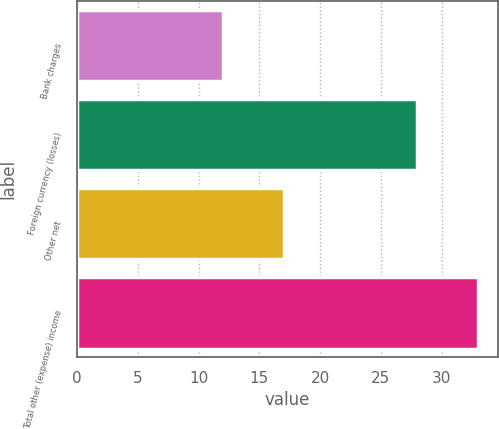Convert chart to OTSL. <chart><loc_0><loc_0><loc_500><loc_500><bar_chart><fcel>Bank charges<fcel>Foreign currency (losses)<fcel>Other net<fcel>Total other (expense) income<nl><fcel>12<fcel>28<fcel>17<fcel>33<nl></chart> 